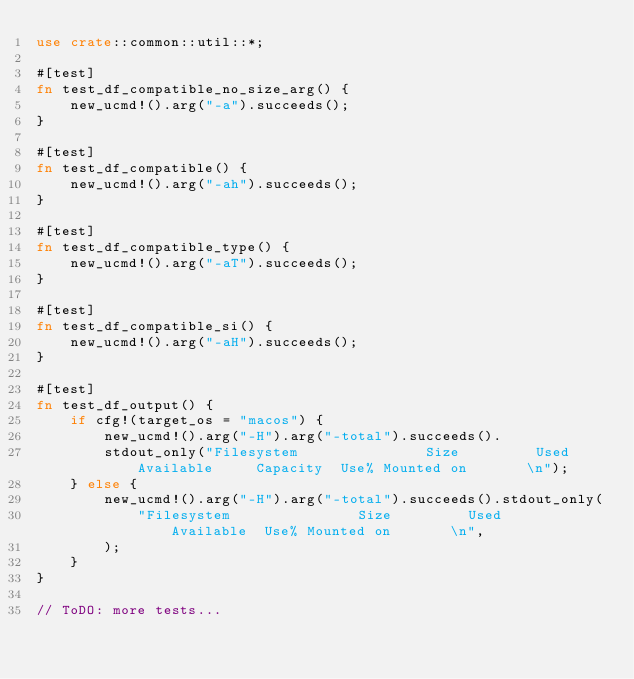Convert code to text. <code><loc_0><loc_0><loc_500><loc_500><_Rust_>use crate::common::util::*;

#[test]
fn test_df_compatible_no_size_arg() {
    new_ucmd!().arg("-a").succeeds();
}

#[test]
fn test_df_compatible() {
    new_ucmd!().arg("-ah").succeeds();
}

#[test]
fn test_df_compatible_type() {
    new_ucmd!().arg("-aT").succeeds();
}

#[test]
fn test_df_compatible_si() {
    new_ucmd!().arg("-aH").succeeds();
}

#[test]
fn test_df_output() {
    if cfg!(target_os = "macos") {
        new_ucmd!().arg("-H").arg("-total").succeeds().
        stdout_only("Filesystem               Size         Used    Available     Capacity  Use% Mounted on       \n");
    } else {
        new_ucmd!().arg("-H").arg("-total").succeeds().stdout_only(
            "Filesystem               Size         Used    Available  Use% Mounted on       \n",
        );
    }
}

// ToDO: more tests...
</code> 